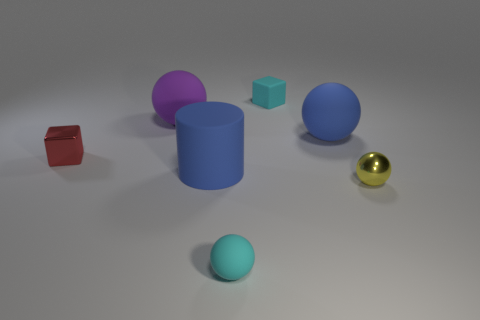Which object seems out of place in this collection, and why? The golden ball seems out of place due to its shiny, reflective surface which contrasts strongly with the matte finishes of the other objects. Additionally, its spherical shape does align with some of the objects but its lustrous texture sets it apart. 